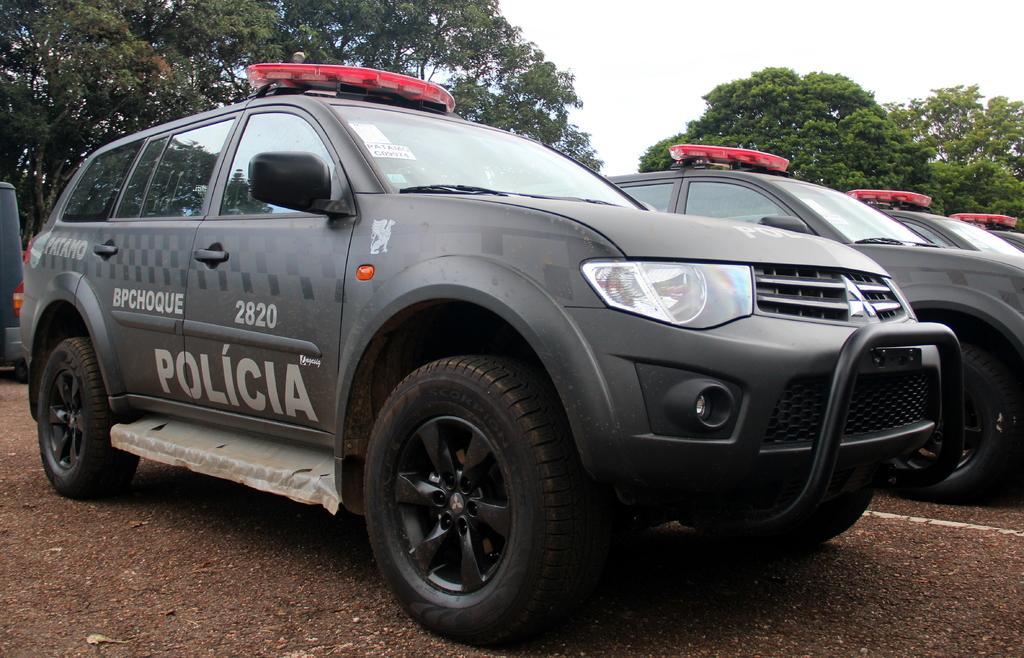Could you give a brief overview of what you see in this image? In the center of the image there are cars. In the background of the image there are trees. At the bottom of the image there is road. 